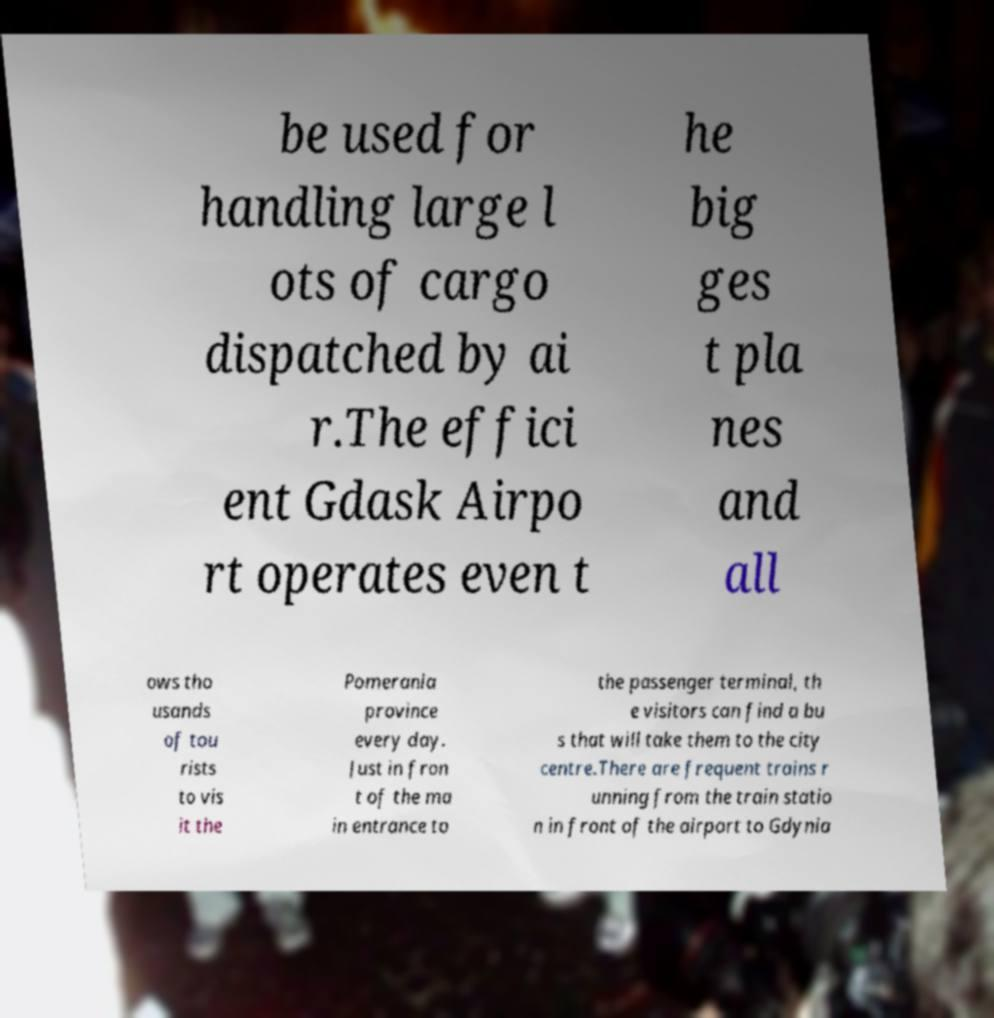Please identify and transcribe the text found in this image. be used for handling large l ots of cargo dispatched by ai r.The effici ent Gdask Airpo rt operates even t he big ges t pla nes and all ows tho usands of tou rists to vis it the Pomerania province every day. Just in fron t of the ma in entrance to the passenger terminal, th e visitors can find a bu s that will take them to the city centre.There are frequent trains r unning from the train statio n in front of the airport to Gdynia 